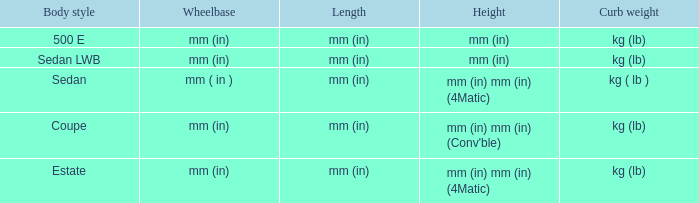What's the length of the model with 500 E body style? Mm (in). 